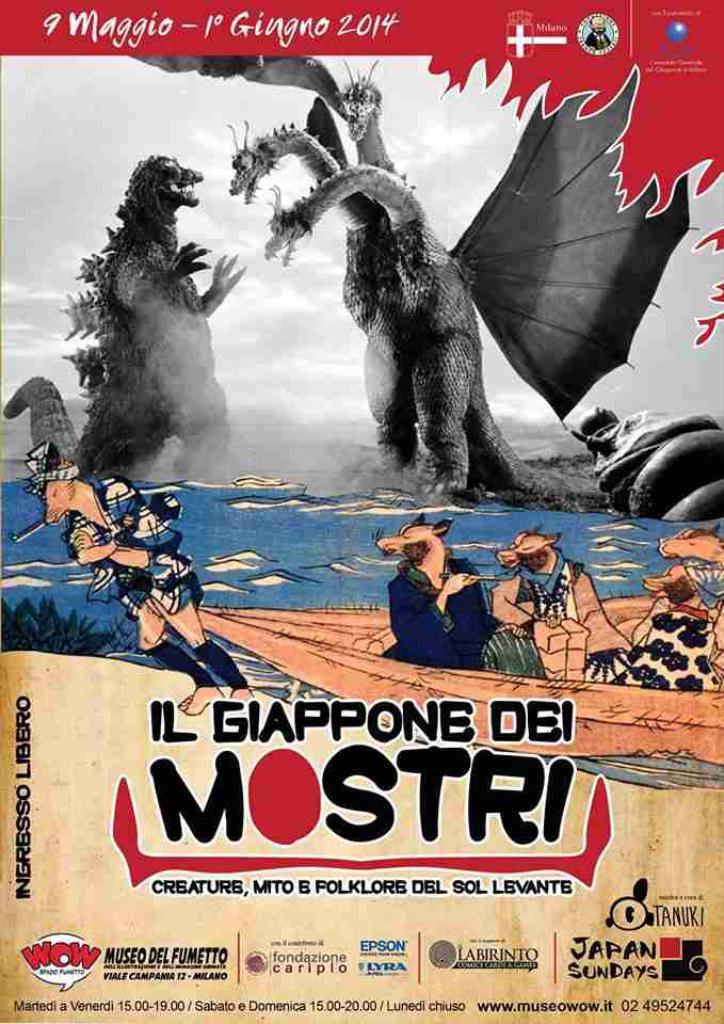What year is at the top of the magazine?
Ensure brevity in your answer.  2014. 